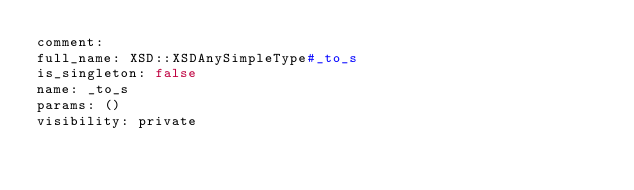<code> <loc_0><loc_0><loc_500><loc_500><_YAML_>comment: 
full_name: XSD::XSDAnySimpleType#_to_s
is_singleton: false
name: _to_s
params: ()
visibility: private
</code> 